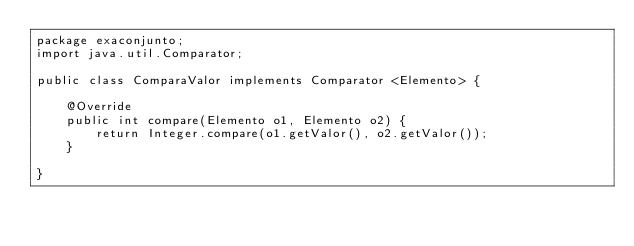Convert code to text. <code><loc_0><loc_0><loc_500><loc_500><_Java_>package exaconjunto;
import java.util.Comparator;

public class ComparaValor implements Comparator <Elemento> {

    @Override
    public int compare(Elemento o1, Elemento o2) {
        return Integer.compare(o1.getValor(), o2.getValor());
    }
     
}
</code> 